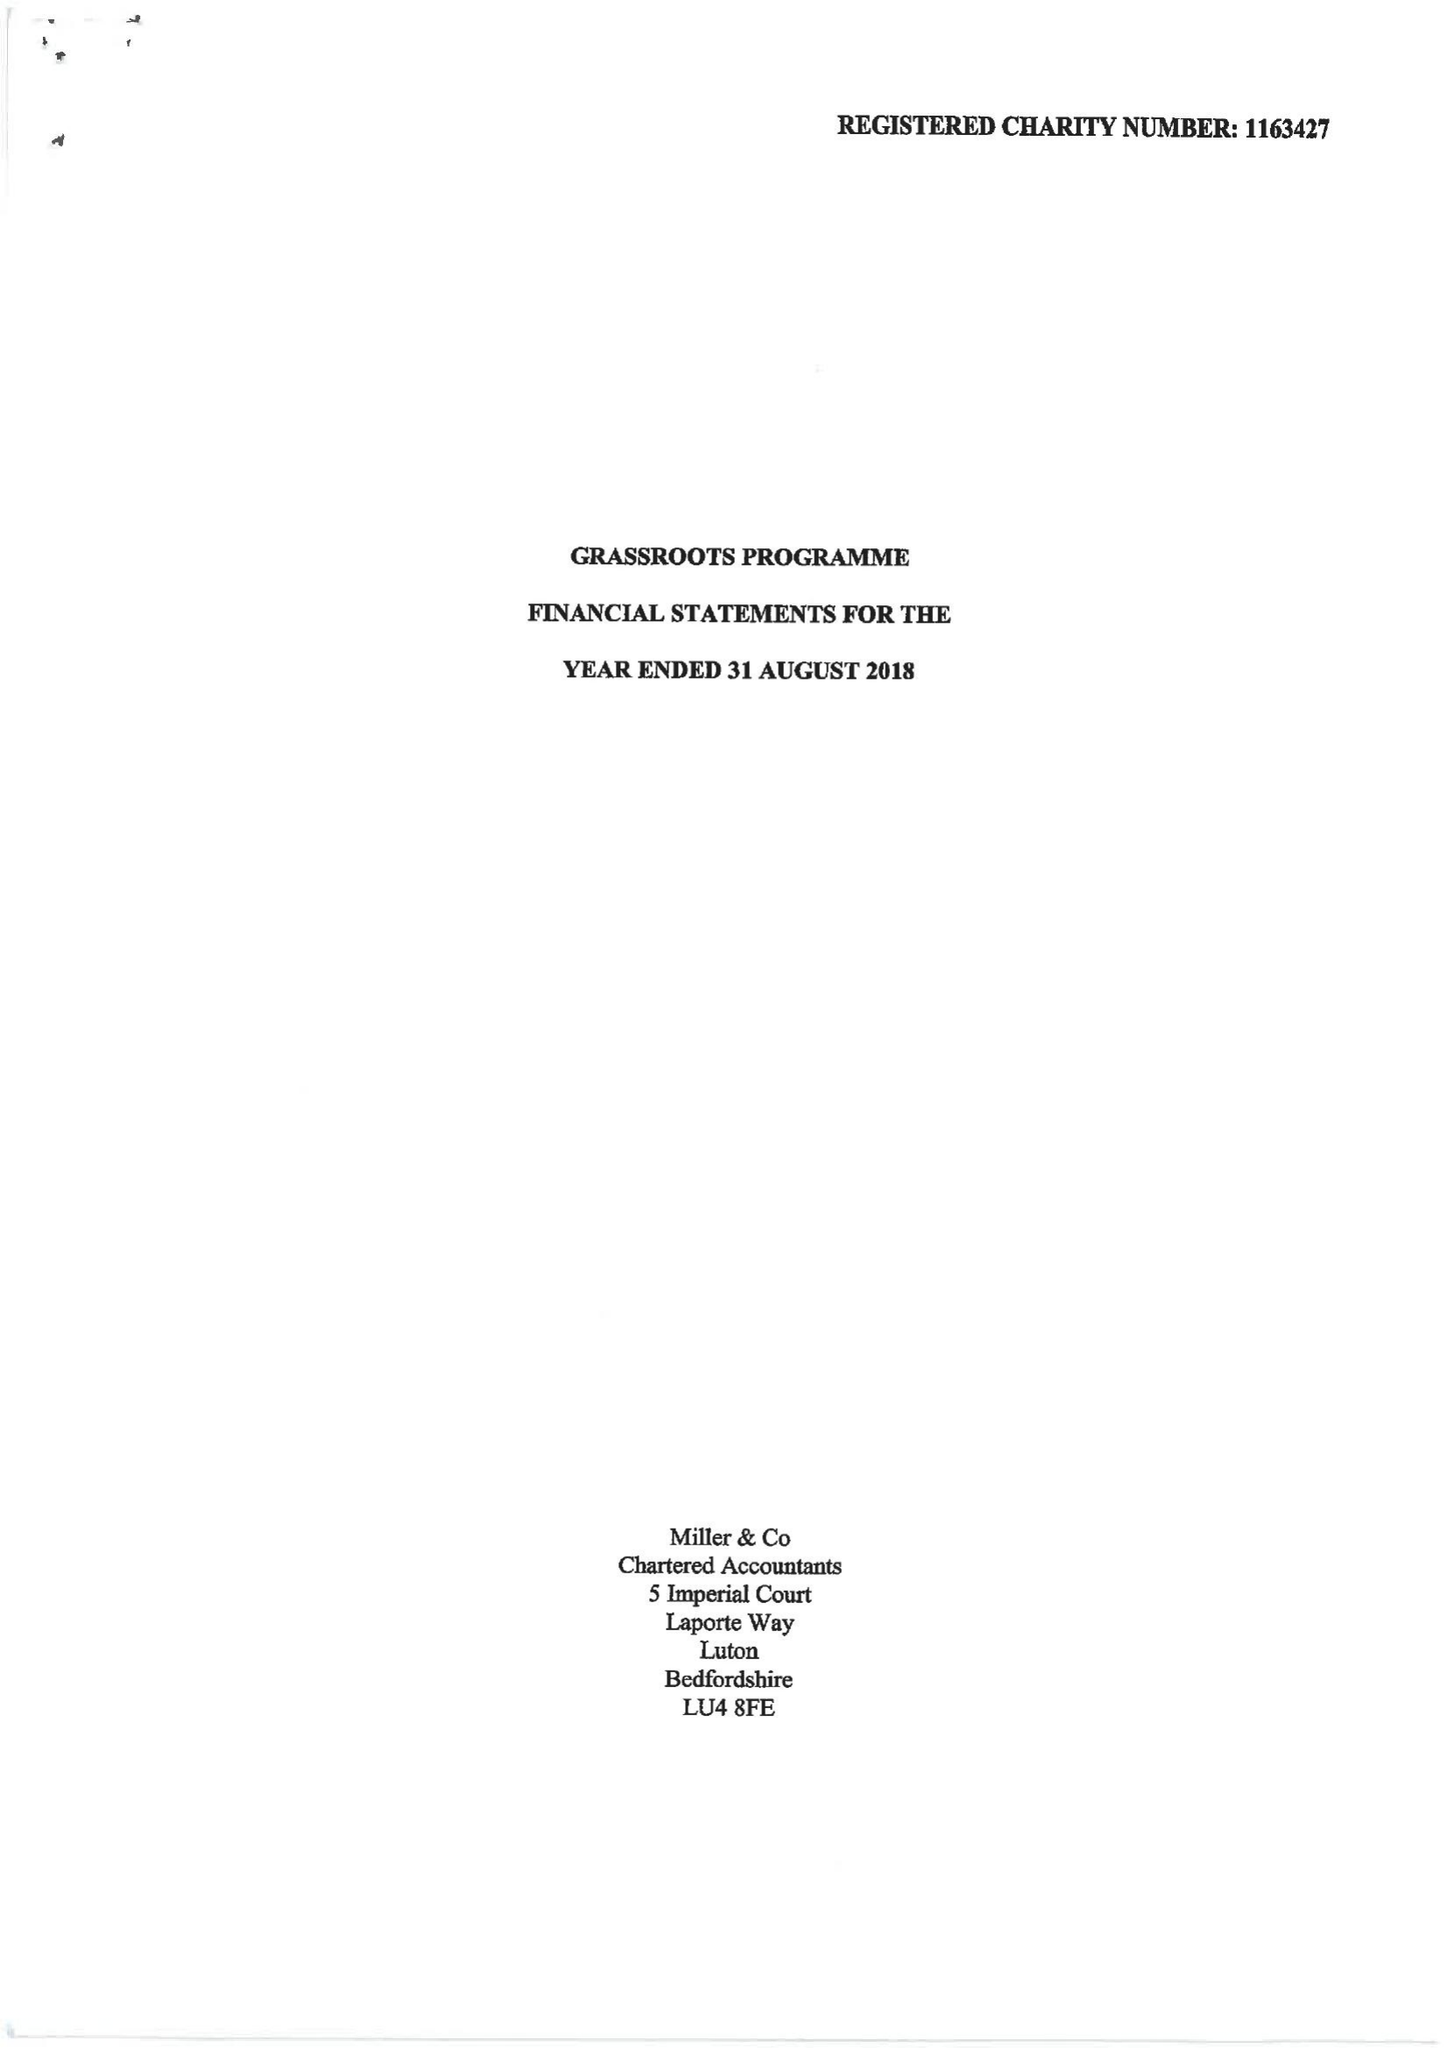What is the value for the income_annually_in_british_pounds?
Answer the question using a single word or phrase. 156192.00 